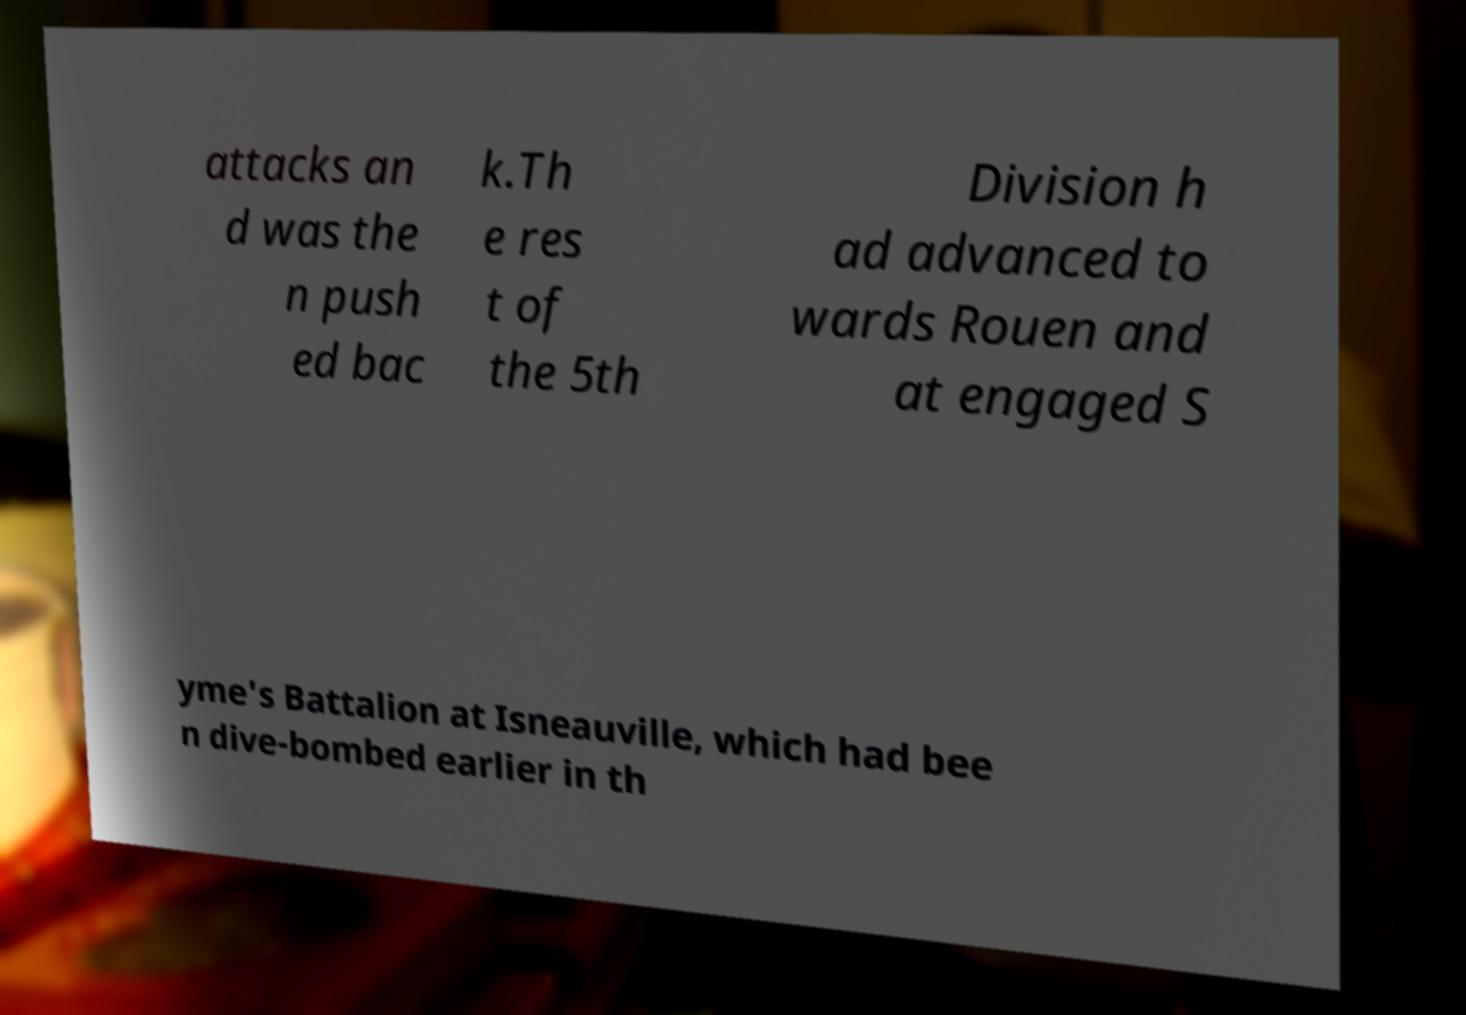Could you extract and type out the text from this image? attacks an d was the n push ed bac k.Th e res t of the 5th Division h ad advanced to wards Rouen and at engaged S yme's Battalion at Isneauville, which had bee n dive-bombed earlier in th 